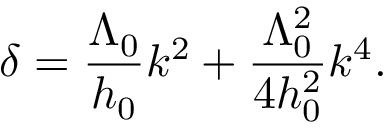<formula> <loc_0><loc_0><loc_500><loc_500>\delta = \frac { \Lambda _ { 0 } } { h _ { 0 } } k ^ { 2 } + \frac { \Lambda _ { 0 } ^ { 2 } } { 4 h _ { 0 } ^ { 2 } } k ^ { 4 } .</formula> 